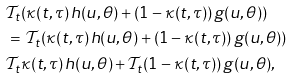Convert formula to latex. <formula><loc_0><loc_0><loc_500><loc_500>& \mathcal { T } _ { t } ( \kappa ( t , \tau ) \, h ( u , \theta ) + ( 1 - \kappa ( t , \tau ) ) \, g ( u , \theta ) ) \\ & = \, \mathcal { T } _ { t } ( \kappa ( t , \tau ) \, h ( u , \theta ) + ( 1 - \kappa ( t , \tau ) ) \, g ( u , \theta ) ) \\ & \mathcal { T } _ { t } \kappa ( t , \tau ) \, h ( u , \theta ) + \mathcal { T } _ { t } ( 1 - \kappa ( t , \tau ) ) \, g ( u , \theta ) ,</formula> 